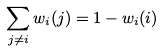<formula> <loc_0><loc_0><loc_500><loc_500>\sum _ { j \neq i } w _ { i } ( j ) = 1 - w _ { i } ( i )</formula> 